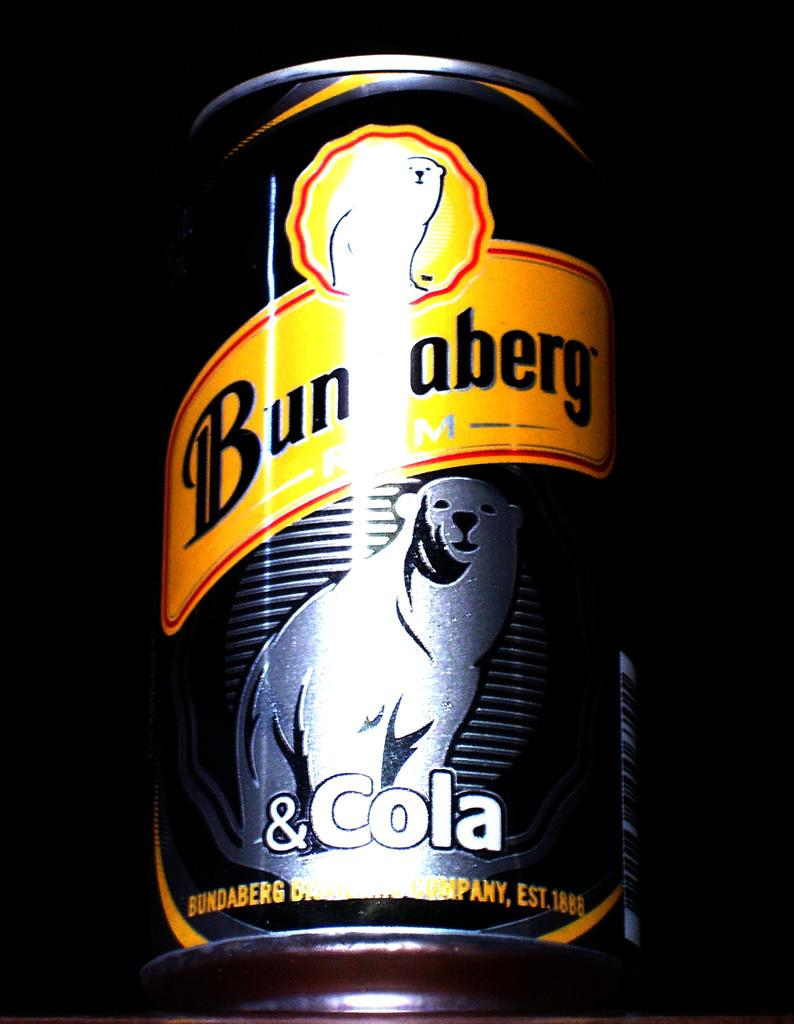Provide a one-sentence caption for the provided image. A polar bear is on a can of Bunaberg cola. 